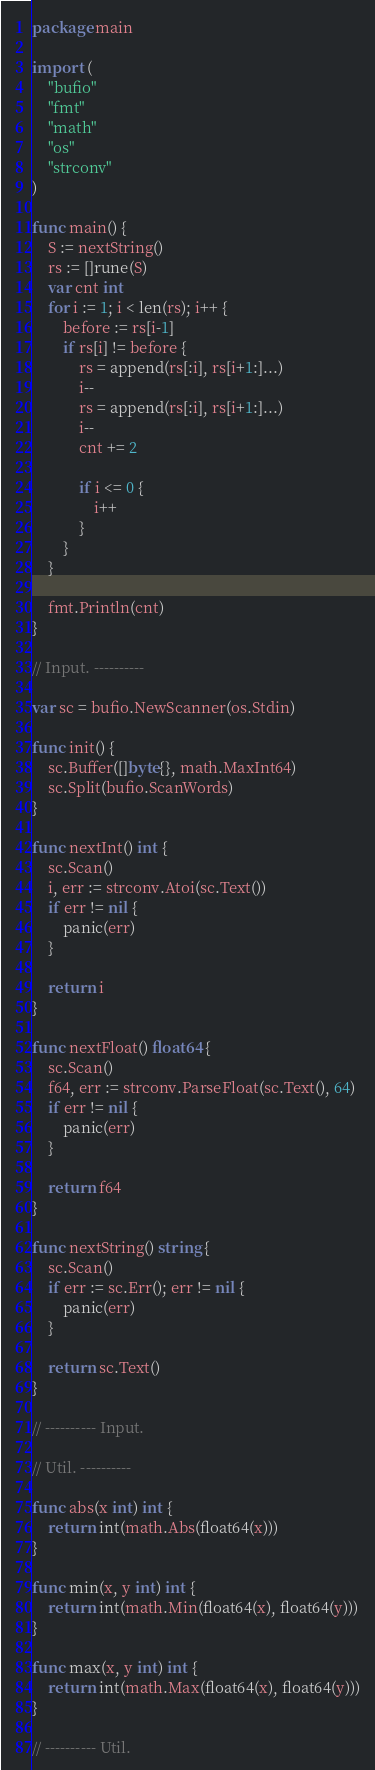Convert code to text. <code><loc_0><loc_0><loc_500><loc_500><_Go_>package main

import (
	"bufio"
	"fmt"
	"math"
	"os"
	"strconv"
)

func main() {
	S := nextString()
	rs := []rune(S)
	var cnt int
	for i := 1; i < len(rs); i++ {
		before := rs[i-1]
		if rs[i] != before {
			rs = append(rs[:i], rs[i+1:]...)
			i--
			rs = append(rs[:i], rs[i+1:]...)
			i--
			cnt += 2

			if i <= 0 {
				i++
			}
		}
	}

	fmt.Println(cnt)
}

// Input. ----------

var sc = bufio.NewScanner(os.Stdin)

func init() {
	sc.Buffer([]byte{}, math.MaxInt64)
	sc.Split(bufio.ScanWords)
}

func nextInt() int {
	sc.Scan()
	i, err := strconv.Atoi(sc.Text())
	if err != nil {
		panic(err)
	}

	return i
}

func nextFloat() float64 {
	sc.Scan()
	f64, err := strconv.ParseFloat(sc.Text(), 64)
	if err != nil {
		panic(err)
	}

	return f64
}

func nextString() string {
	sc.Scan()
	if err := sc.Err(); err != nil {
		panic(err)
	}

	return sc.Text()
}

// ---------- Input.

// Util. ----------

func abs(x int) int {
	return int(math.Abs(float64(x)))
}

func min(x, y int) int {
	return int(math.Min(float64(x), float64(y)))
}

func max(x, y int) int {
	return int(math.Max(float64(x), float64(y)))
}

// ---------- Util.
</code> 